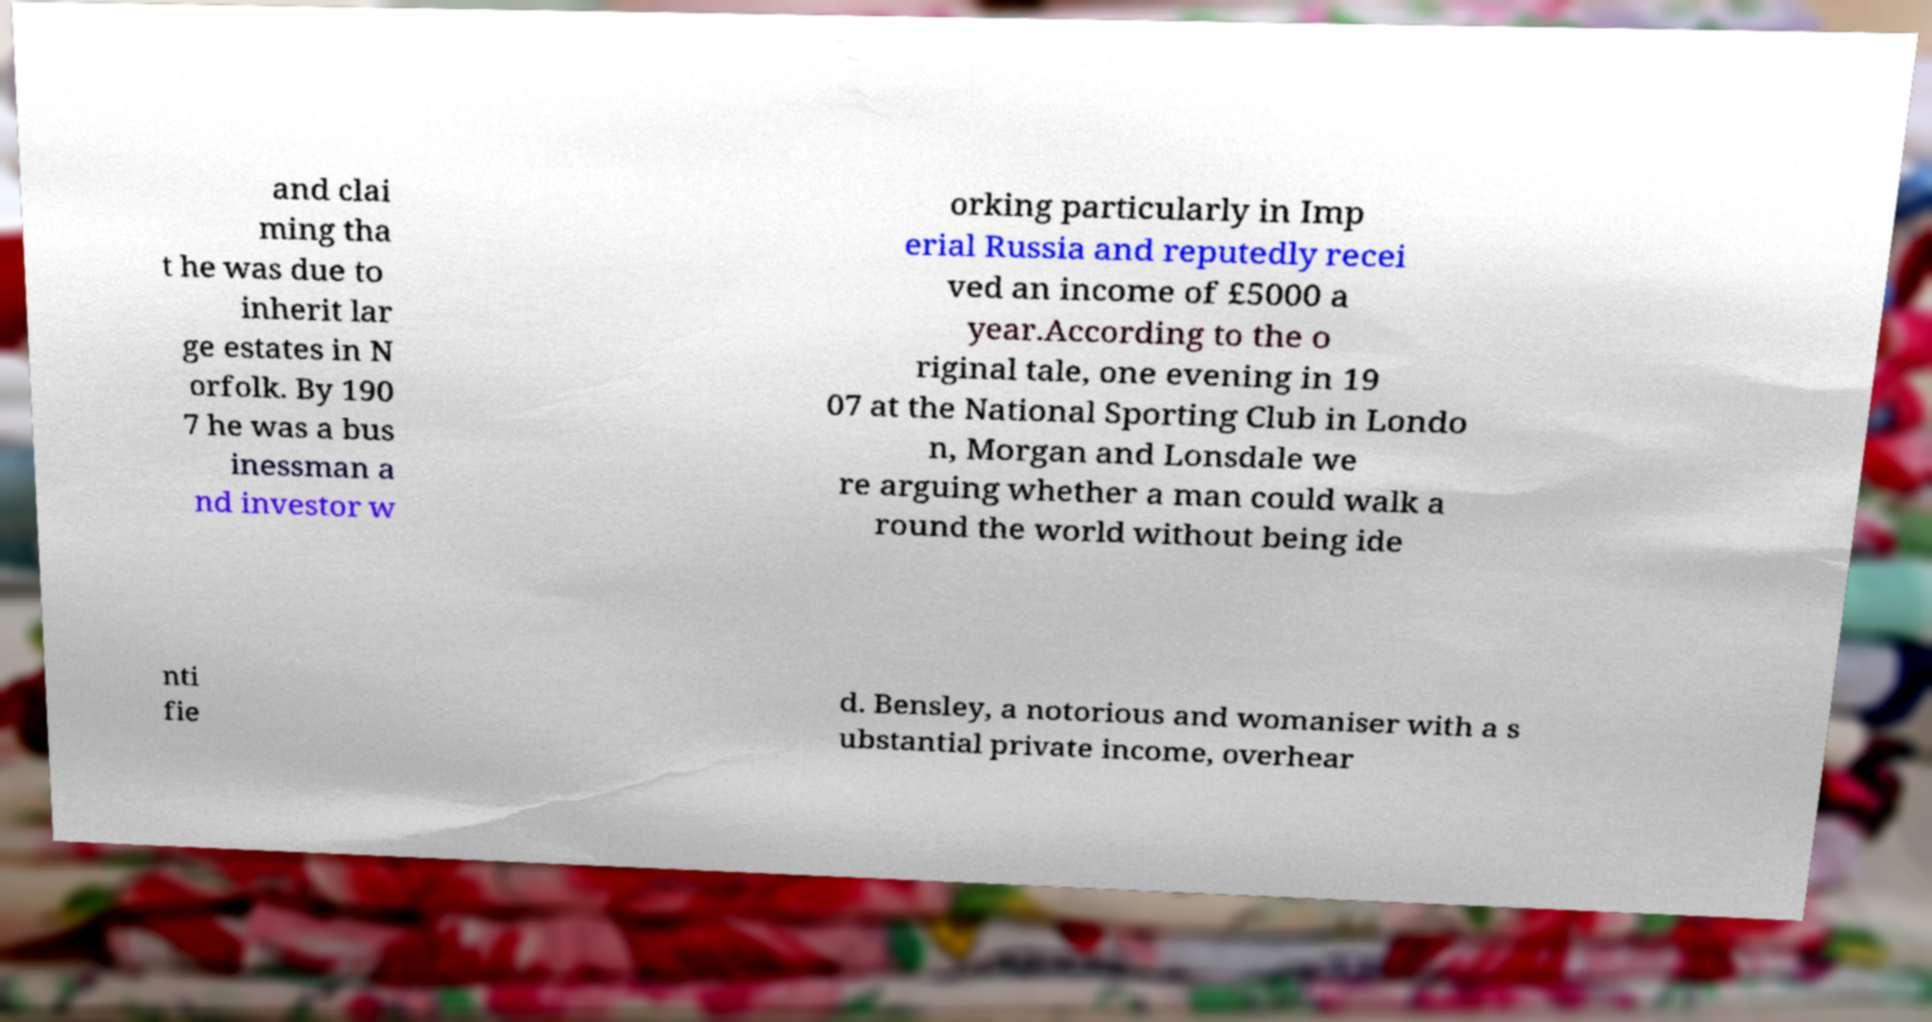What messages or text are displayed in this image? I need them in a readable, typed format. and clai ming tha t he was due to inherit lar ge estates in N orfolk. By 190 7 he was a bus inessman a nd investor w orking particularly in Imp erial Russia and reputedly recei ved an income of £5000 a year.According to the o riginal tale, one evening in 19 07 at the National Sporting Club in Londo n, Morgan and Lonsdale we re arguing whether a man could walk a round the world without being ide nti fie d. Bensley, a notorious and womaniser with a s ubstantial private income, overhear 